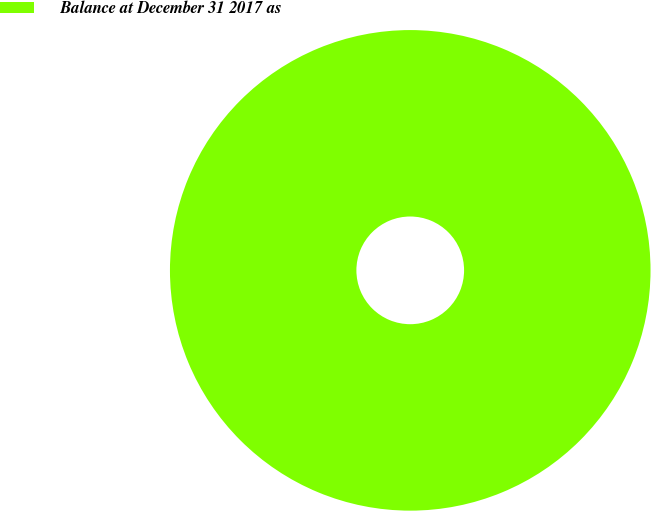Convert chart to OTSL. <chart><loc_0><loc_0><loc_500><loc_500><pie_chart><fcel>Balance at December 31 2017 as<nl><fcel>100.0%<nl></chart> 